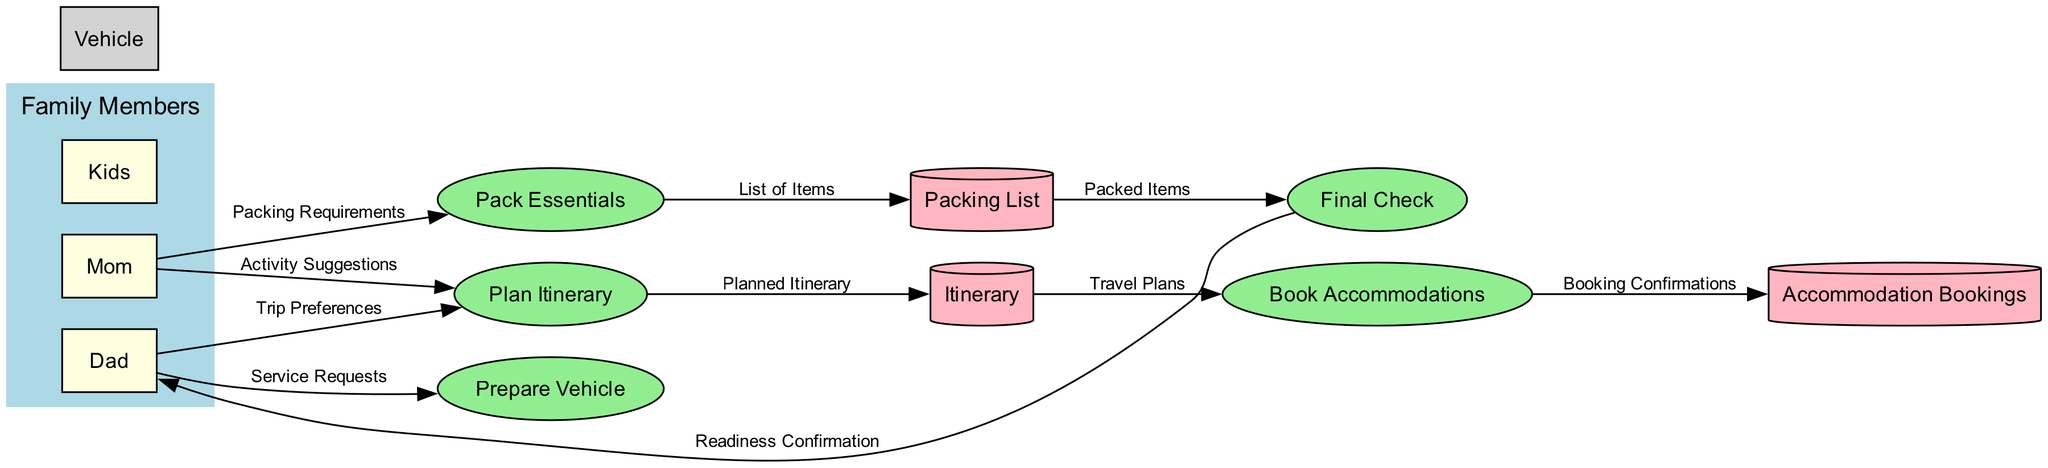What is the primary responsibility of Dad in the diagram? The primary responsibility of Dad in the diagram is to organize the road trip, which is evident from the "Dad" node directly linked to various processes like "Plan Itinerary" and "Prepare Vehicle."
Answer: Organizing the road trip How many processes are displayed in the diagram? The diagram shows a total of five processes, which are "Plan Itinerary," "Book Accommodations," "Prepare Vehicle," "Pack Essentials," and "Final Check."
Answer: Five Which process follows after "Plan Itinerary"? After "Plan Itinerary," the next process is "Book Accommodations," as indicated by the data flow directly connecting them with the data "Travel Plans."
Answer: Book Accommodations What type of data does "Book Accommodations" generate? "Book Accommodations" generates "Booking Confirmations," which is evidenced by the data flow that transitions from the "Book Accommodations" process to the "Accommodation Bookings" data store.
Answer: Booking Confirmations What data flows from "Packing List" to "Final Check"? The data flowing from "Packing List" to "Final Check" is "Packed Items," as the diagram clearly indicates this data flow.
Answer: Packed Items What is the role of Mom in this process? Mom assists with packing and planning, as her involvement is highlighted through data flows to "Plan Itinerary" and "Pack Essentials."
Answer: Assists with packing and planning Which entity is responsible for gathering necessary items for the trip? The entity responsible for gathering the necessary items, such as clothes and snacks, is "Mom," as indicated by the data flow from "Mom" to "Pack Essentials."
Answer: Mom How does "Prepare Vehicle" relate to "Final Check"? "Prepare Vehicle" is indirectly related to "Final Check" through "Dad," who ensures the vehicle readiness and is involved in the overall readiness check process before departure.
Answer: Indirectly related through Dad Which data store holds the trip's planned activities and destinations? The "Itinerary" data store holds the trip's planned activities and destinations, as shown in the data flow from "Plan Itinerary" to "Itinerary."
Answer: Itinerary 